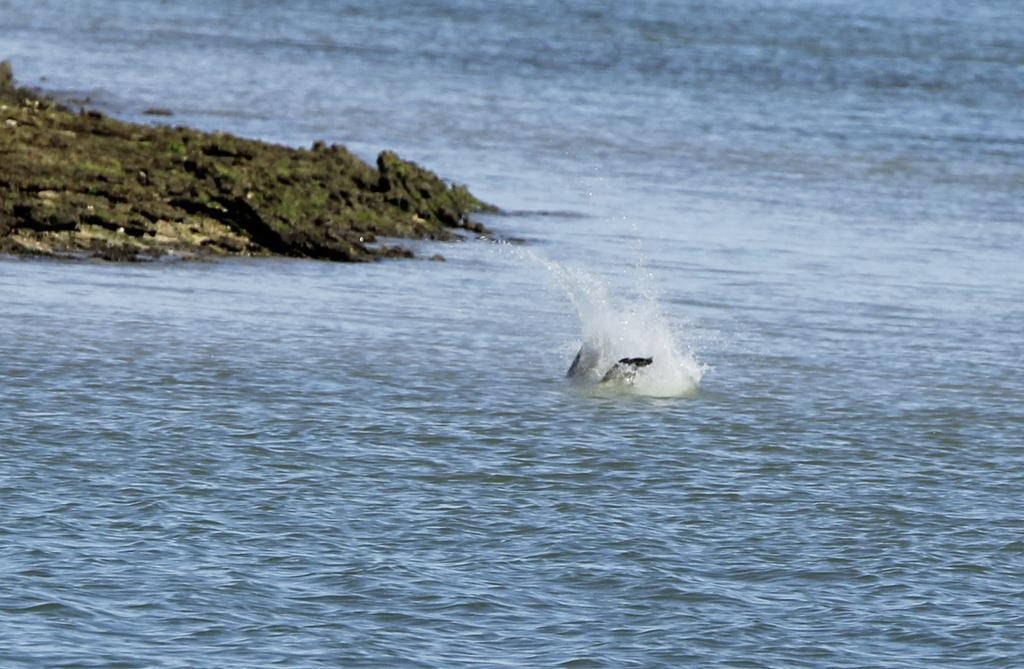What is the main subject in the center of the image? There is a fish in the water in the center of the image. What can be seen on the left side of the image? There is a rock on the left side of the image. How much credit does the fish have in the image? There is no mention of credit or any financial aspect in the image, as it features a fish in the water and a rock. 